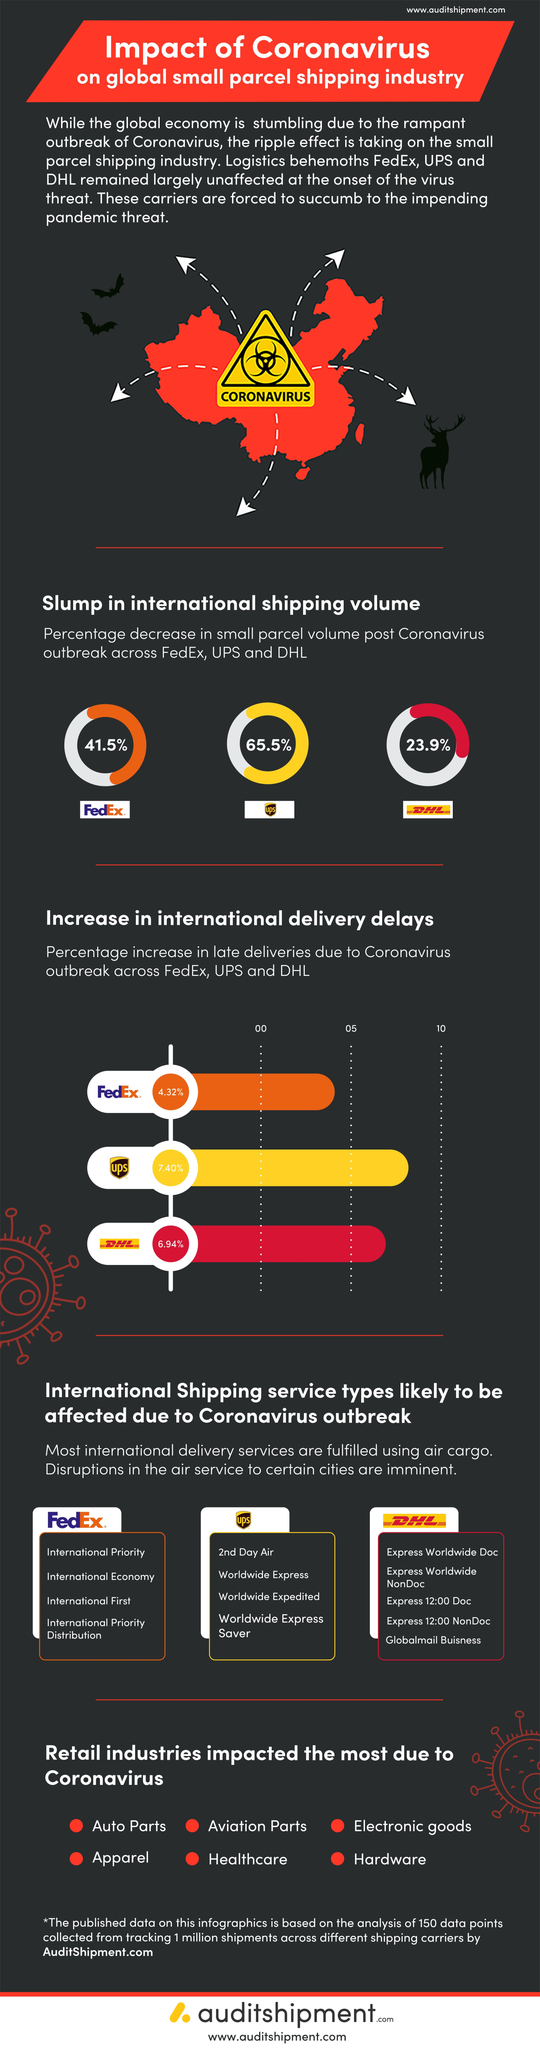What is the percentage decrease in the international shipping volume of UPS during the post Covid time?
Answer the question with a short phrase. 65.5% Which logistics company has shown the highest percent of increase in the late deliveries among the others due to coronavirus outbreak? UPS What is the percentage decrease in small parcel volume of FedEx during the post Covid time? 41.5% What is the percentage decrease in small parcel volume of DHL  during the post Covid time? 23.9% 